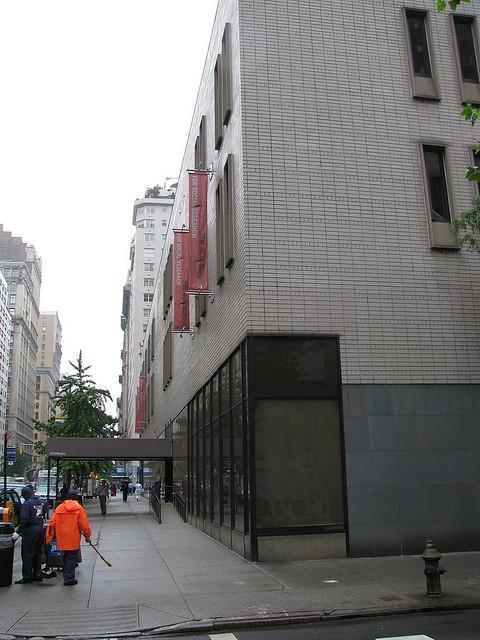How many flags are there?
Give a very brief answer. 0. How many people are wearing white?
Give a very brief answer. 0. How many people are there?
Give a very brief answer. 2. 